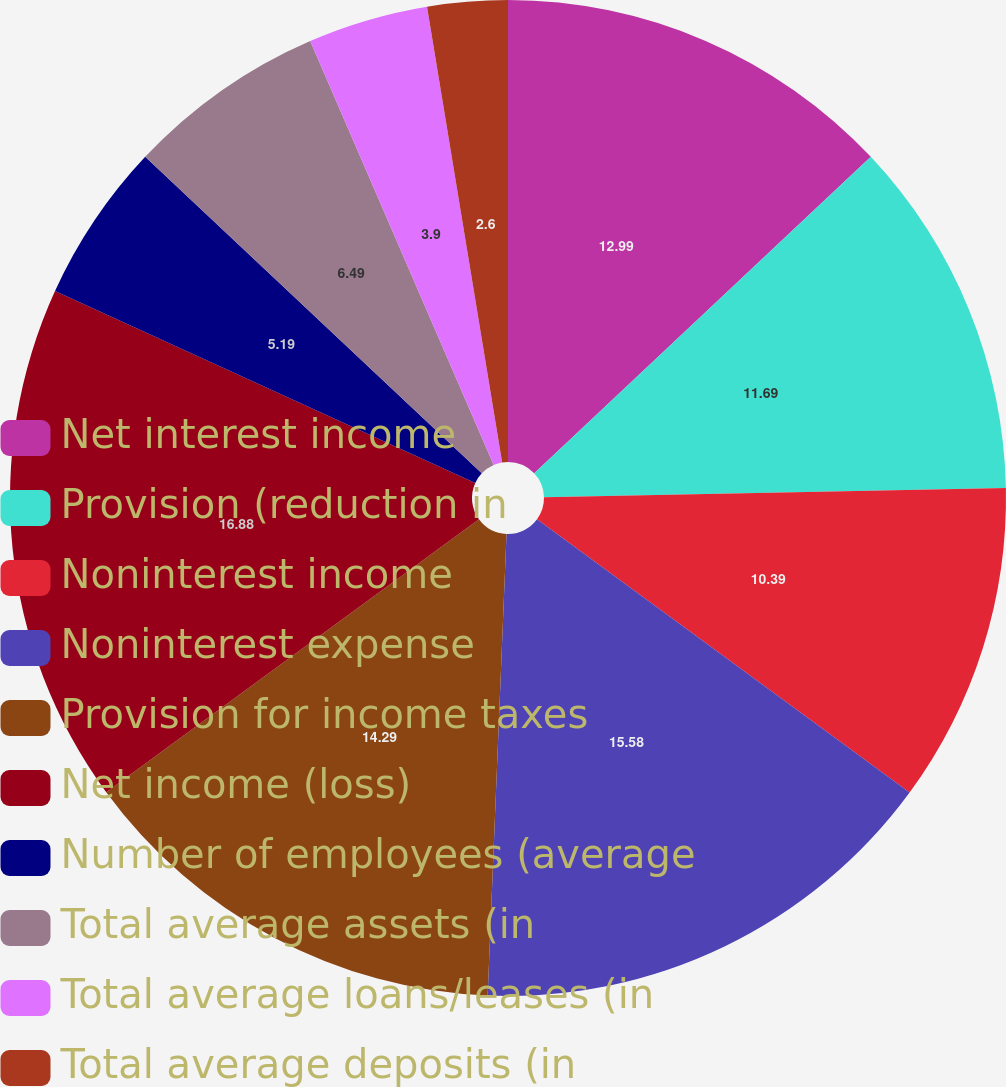<chart> <loc_0><loc_0><loc_500><loc_500><pie_chart><fcel>Net interest income<fcel>Provision (reduction in<fcel>Noninterest income<fcel>Noninterest expense<fcel>Provision for income taxes<fcel>Net income (loss)<fcel>Number of employees (average<fcel>Total average assets (in<fcel>Total average loans/leases (in<fcel>Total average deposits (in<nl><fcel>12.99%<fcel>11.69%<fcel>10.39%<fcel>15.58%<fcel>14.29%<fcel>16.88%<fcel>5.19%<fcel>6.49%<fcel>3.9%<fcel>2.6%<nl></chart> 